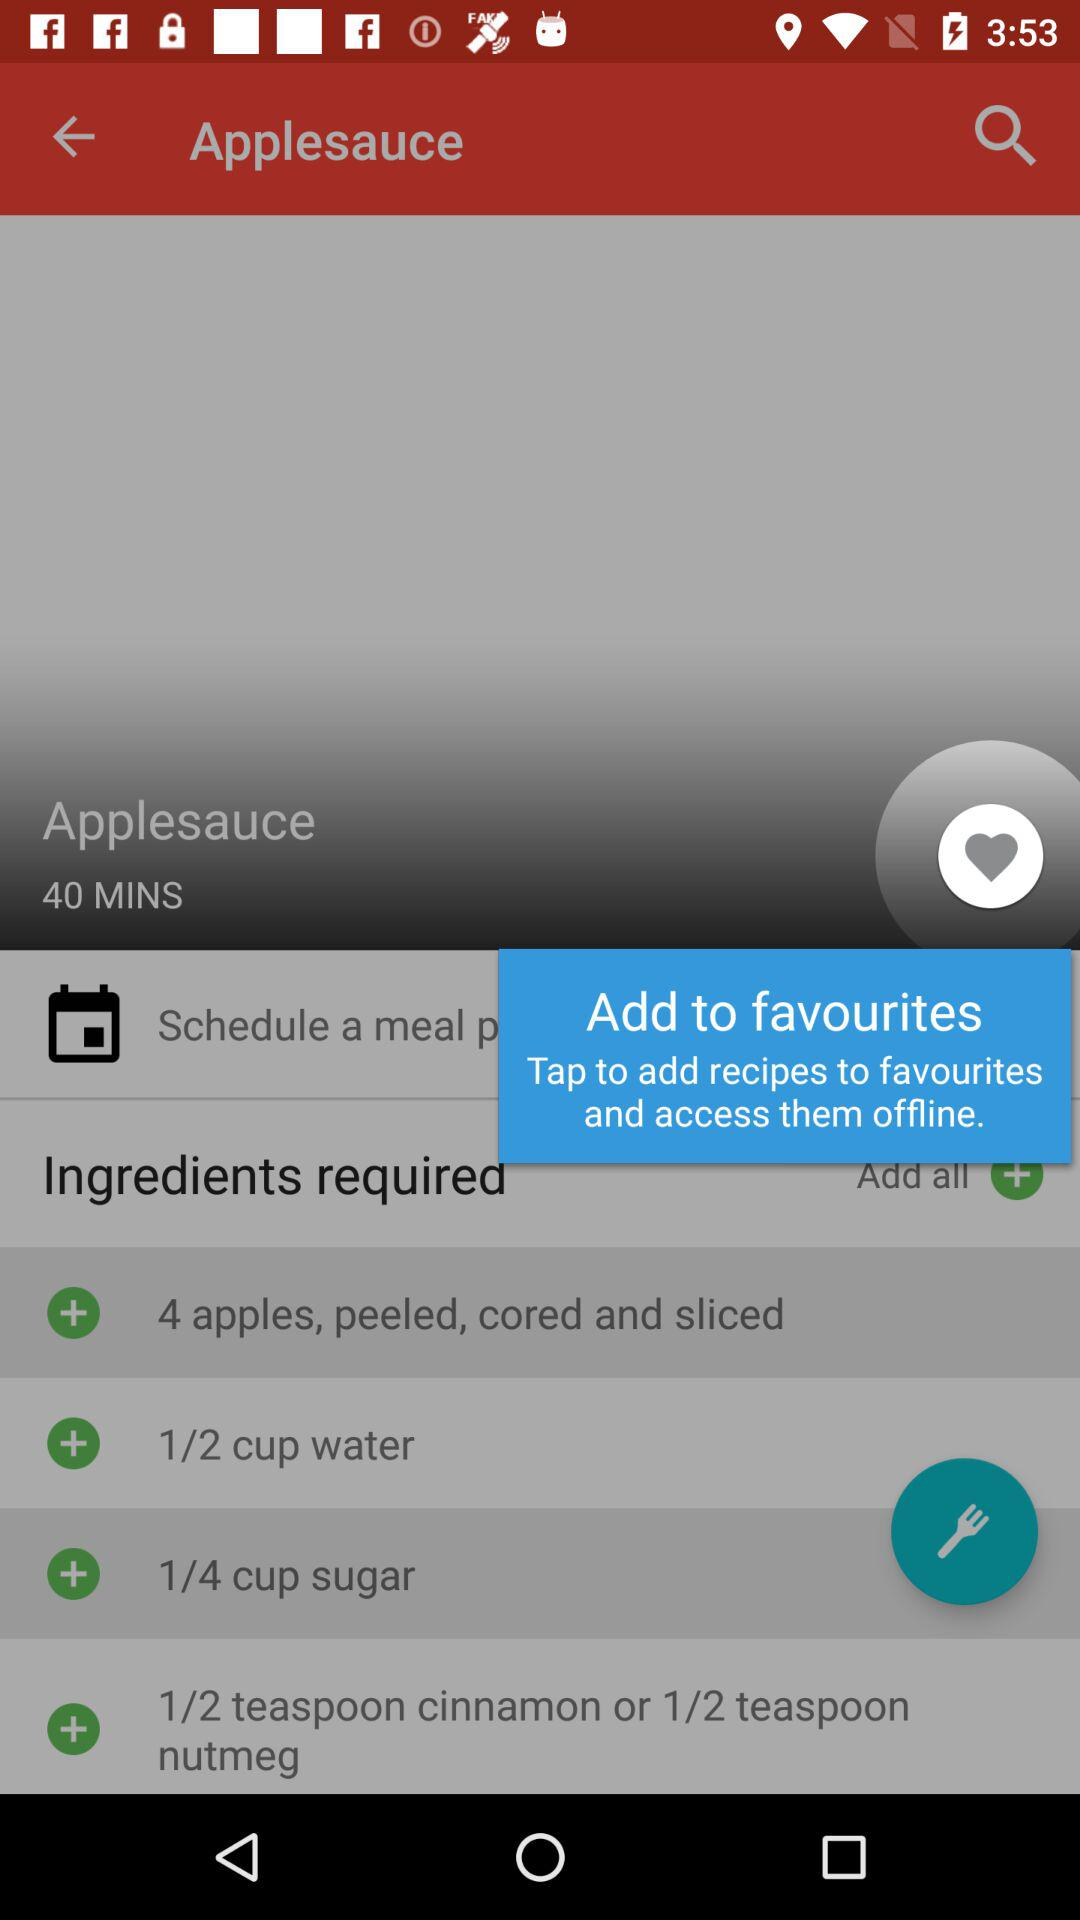How many minutes does it take to make applesauce?
Answer the question using a single word or phrase. 40 